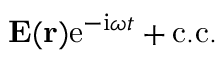<formula> <loc_0><loc_0><loc_500><loc_500>{ E } ( { r } ) e ^ { - i \omega t } + c . c .</formula> 